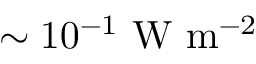Convert formula to latex. <formula><loc_0><loc_0><loc_500><loc_500>\sim 1 0 ^ { - 1 } W m ^ { - 2 }</formula> 